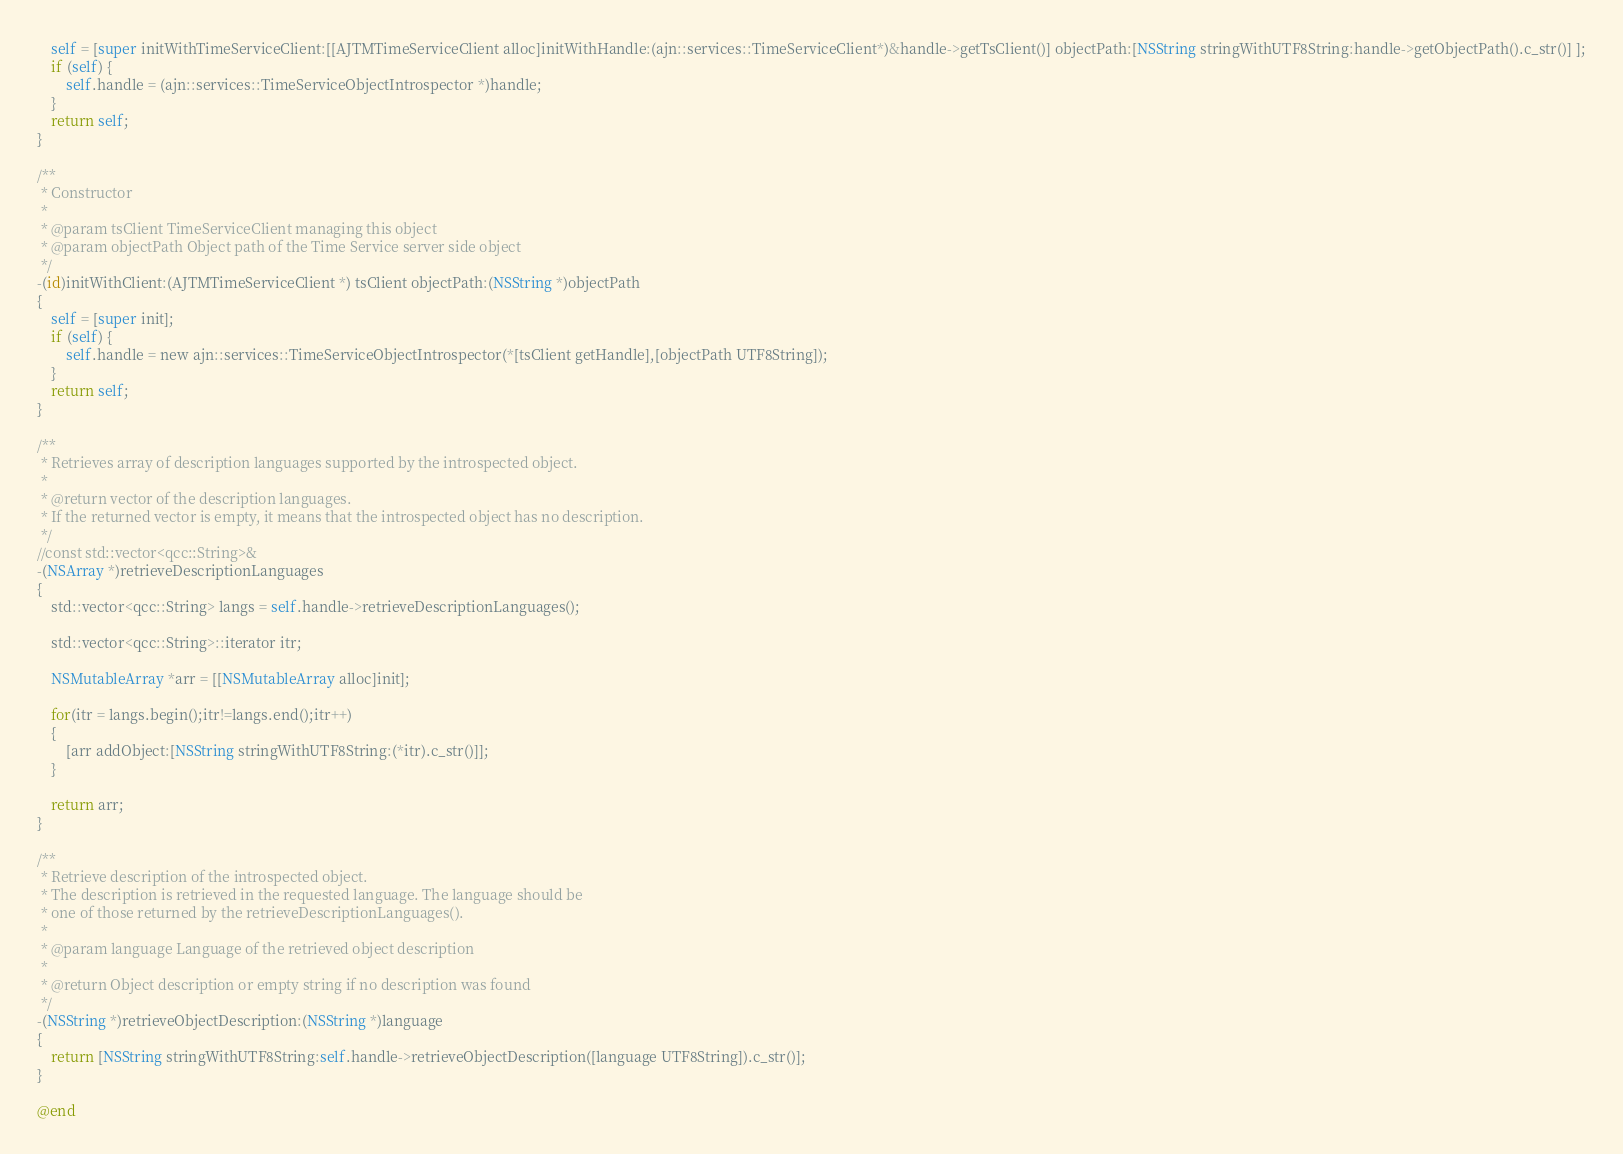Convert code to text. <code><loc_0><loc_0><loc_500><loc_500><_ObjectiveC_>    self = [super initWithTimeServiceClient:[[AJTMTimeServiceClient alloc]initWithHandle:(ajn::services::TimeServiceClient*)&handle->getTsClient()] objectPath:[NSString stringWithUTF8String:handle->getObjectPath().c_str()] ];
    if (self) {
        self.handle = (ajn::services::TimeServiceObjectIntrospector *)handle;
    }
    return self;
}

/**
 * Constructor
 *
 * @param tsClient TimeServiceClient managing this object
 * @param objectPath Object path of the Time Service server side object
 */
-(id)initWithClient:(AJTMTimeServiceClient *) tsClient objectPath:(NSString *)objectPath
{
    self = [super init];
    if (self) {
        self.handle = new ajn::services::TimeServiceObjectIntrospector(*[tsClient getHandle],[objectPath UTF8String]);
    }
    return self;
}

/**
 * Retrieves array of description languages supported by the introspected object.
 *
 * @return vector of the description languages.
 * If the returned vector is empty, it means that the introspected object has no description.
 */
//const std::vector<qcc::String>&
-(NSArray *)retrieveDescriptionLanguages
{
    std::vector<qcc::String> langs = self.handle->retrieveDescriptionLanguages();

    std::vector<qcc::String>::iterator itr;

    NSMutableArray *arr = [[NSMutableArray alloc]init];

    for(itr = langs.begin();itr!=langs.end();itr++)
    {
        [arr addObject:[NSString stringWithUTF8String:(*itr).c_str()]];
    }

    return arr;
}

/**
 * Retrieve description of the introspected object.
 * The description is retrieved in the requested language. The language should be
 * one of those returned by the retrieveDescriptionLanguages().
 *
 * @param language Language of the retrieved object description
 *
 * @return Object description or empty string if no description was found
 */
-(NSString *)retrieveObjectDescription:(NSString *)language
{
    return [NSString stringWithUTF8String:self.handle->retrieveObjectDescription([language UTF8String]).c_str()];
}

@end</code> 